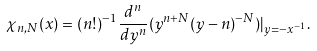<formula> <loc_0><loc_0><loc_500><loc_500>\chi _ { n , N } ( x ) = ( n ! ) ^ { - 1 } \frac { d ^ { n } } { d y ^ { n } } ( y ^ { n + N } ( y - n ) ^ { - N } ) | _ { y = - x ^ { - 1 } } .</formula> 